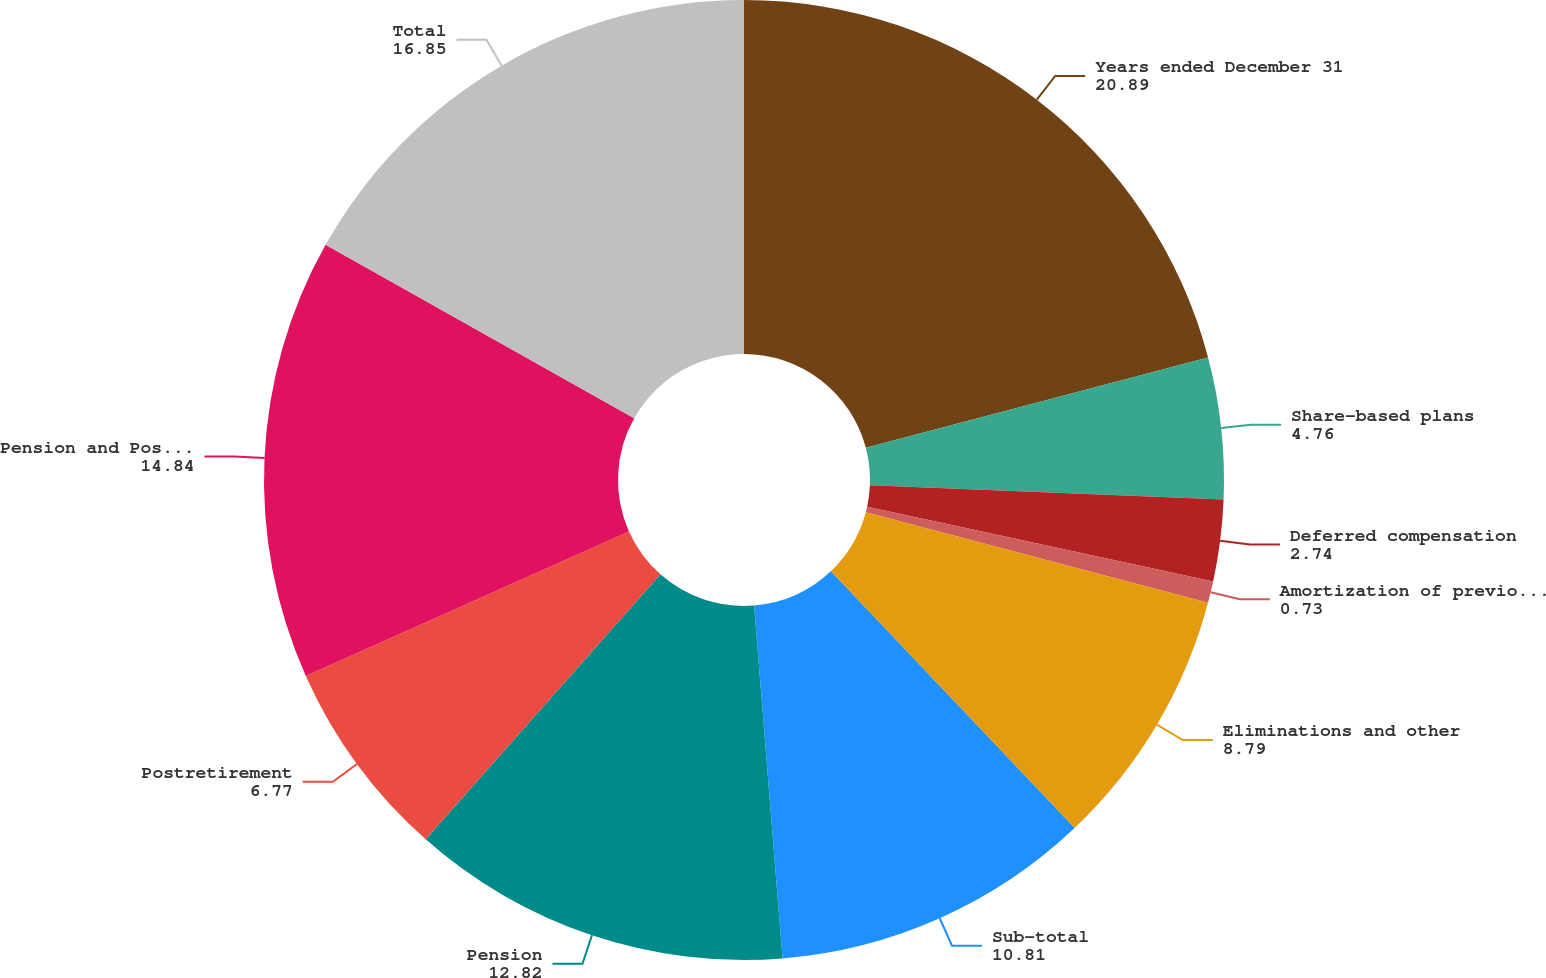<chart> <loc_0><loc_0><loc_500><loc_500><pie_chart><fcel>Years ended December 31<fcel>Share-based plans<fcel>Deferred compensation<fcel>Amortization of previously<fcel>Eliminations and other<fcel>Sub-total<fcel>Pension<fcel>Postretirement<fcel>Pension and Postretirement<fcel>Total<nl><fcel>20.89%<fcel>4.76%<fcel>2.74%<fcel>0.73%<fcel>8.79%<fcel>10.81%<fcel>12.82%<fcel>6.77%<fcel>14.84%<fcel>16.85%<nl></chart> 